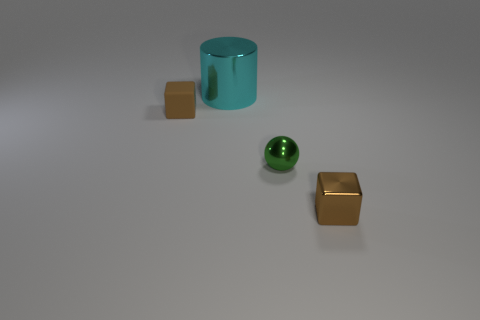Add 3 tiny brown cubes. How many objects exist? 7 Subtract all balls. How many objects are left? 3 Add 3 large cyan objects. How many large cyan objects are left? 4 Add 1 tiny red objects. How many tiny red objects exist? 1 Subtract 0 red cylinders. How many objects are left? 4 Subtract all brown metal things. Subtract all tiny brown objects. How many objects are left? 1 